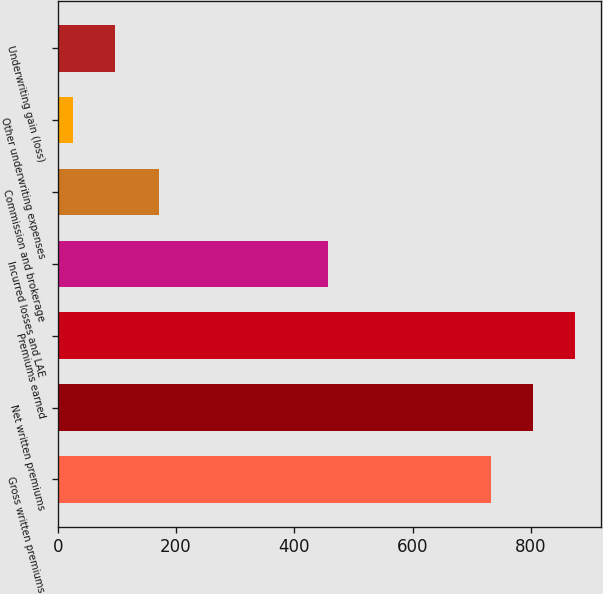<chart> <loc_0><loc_0><loc_500><loc_500><bar_chart><fcel>Gross written premiums<fcel>Net written premiums<fcel>Premiums earned<fcel>Incurred losses and LAE<fcel>Commission and brokerage<fcel>Other underwriting expenses<fcel>Underwriting gain (loss)<nl><fcel>733<fcel>804.2<fcel>875.4<fcel>457.9<fcel>171.1<fcel>26.4<fcel>97.6<nl></chart> 